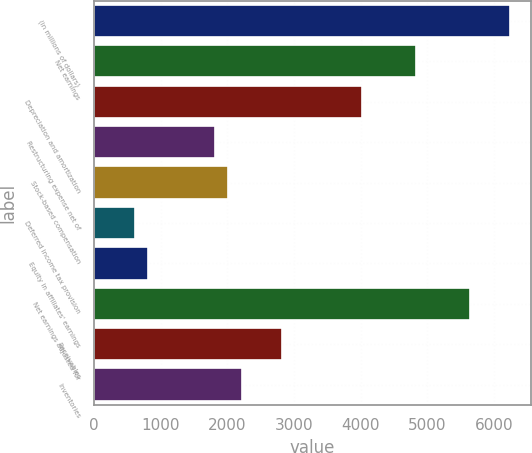Convert chart. <chart><loc_0><loc_0><loc_500><loc_500><bar_chart><fcel>(in millions of dollars)<fcel>Net earnings<fcel>Depreciation and amortization<fcel>Restructuring expense net of<fcel>Stock-based compensation<fcel>Deferred income tax provision<fcel>Equity in affiliates' earnings<fcel>Net earnings adjusted for<fcel>Receivables<fcel>Inventories<nl><fcel>6238.73<fcel>4830.82<fcel>4026.3<fcel>1813.87<fcel>2015<fcel>607.09<fcel>808.22<fcel>5635.34<fcel>2819.52<fcel>2216.13<nl></chart> 